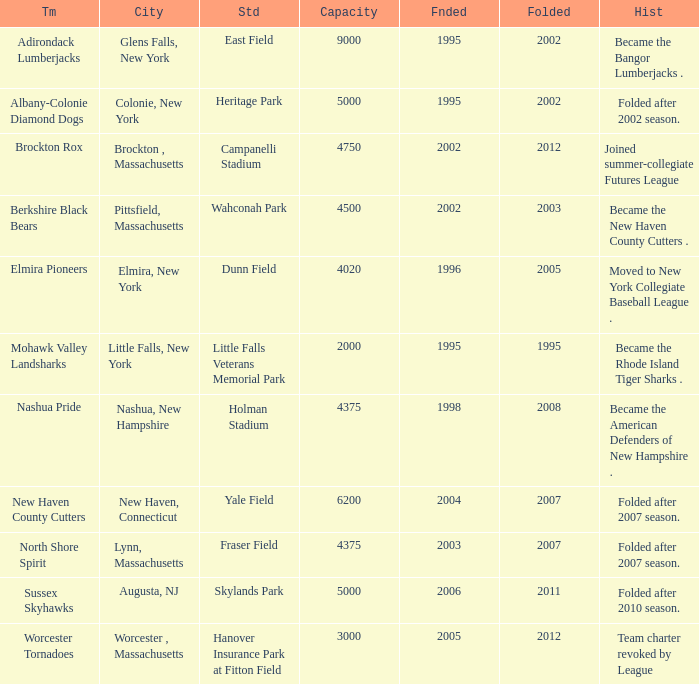What is the maximum folded value of the team whose stadium is Fraser Field? 2007.0. 